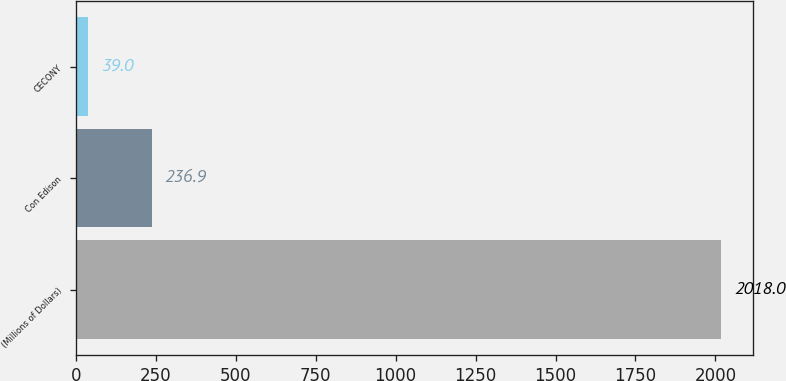Convert chart to OTSL. <chart><loc_0><loc_0><loc_500><loc_500><bar_chart><fcel>(Millions of Dollars)<fcel>Con Edison<fcel>CECONY<nl><fcel>2018<fcel>236.9<fcel>39<nl></chart> 